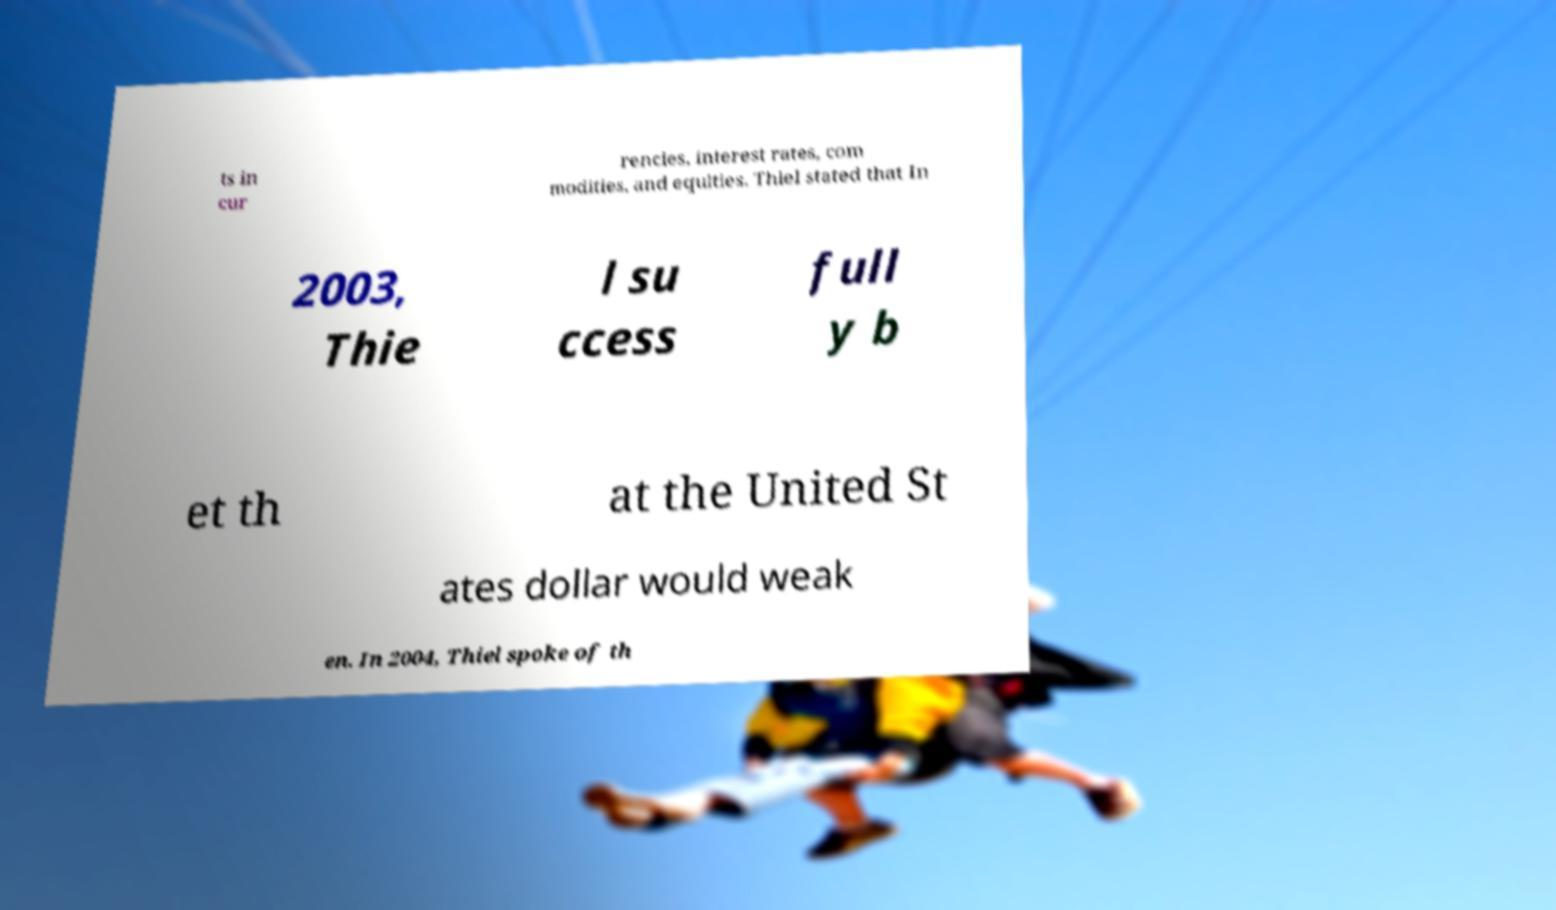Could you extract and type out the text from this image? ts in cur rencies, interest rates, com modities, and equities. Thiel stated that In 2003, Thie l su ccess full y b et th at the United St ates dollar would weak en. In 2004, Thiel spoke of th 